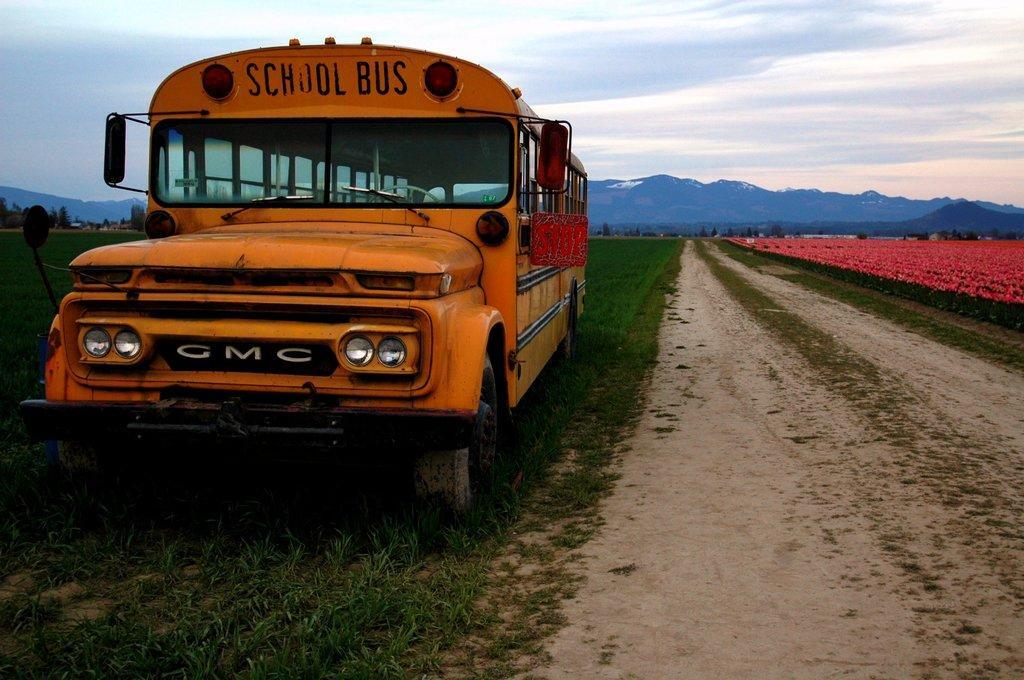Can you describe this image briefly? In this picture we can see a vehicle on the grass, side we can see some flowers to the plants, around we can see some trees. 